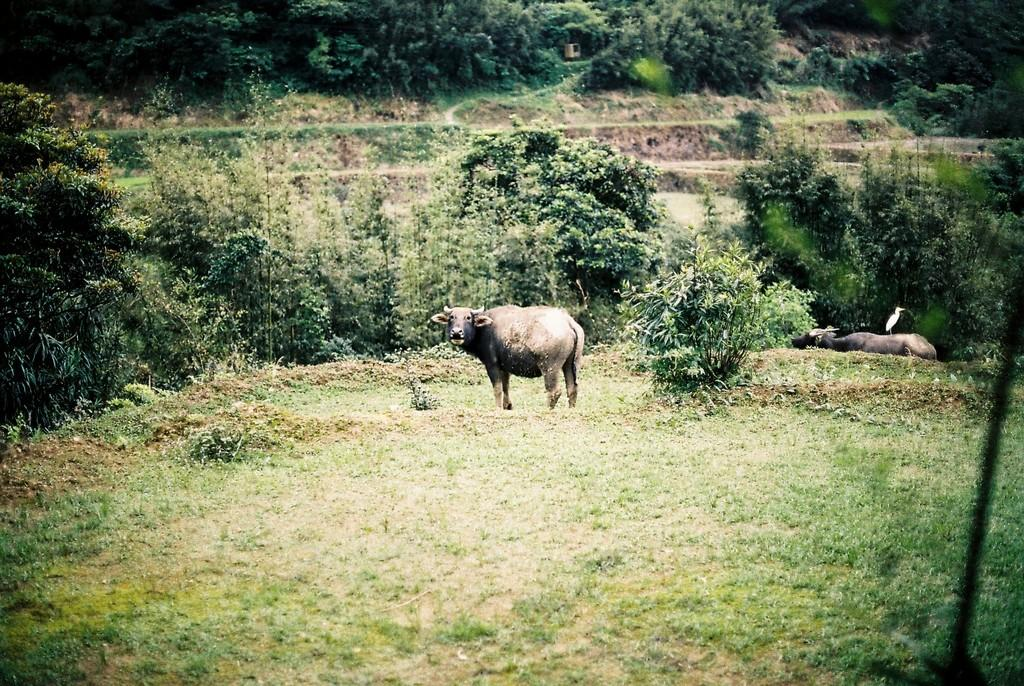What type of animal can be seen on the ground in the image? There is an animal on the ground in the image, but the specific type cannot be determined from the provided facts. What is the bird perched on in the image? The bird is perched on a wooden log in the image. What can be seen in the distance in the image? There are trees visible in the background of the image. What type of linen is draped over the bird in the image? There is no linen present in the image; the bird is perched on a wooden log. Can you tell me how many quills the bird is using to write in the image? Birds do not use quills to write, and there is no indication of writing in the image. 